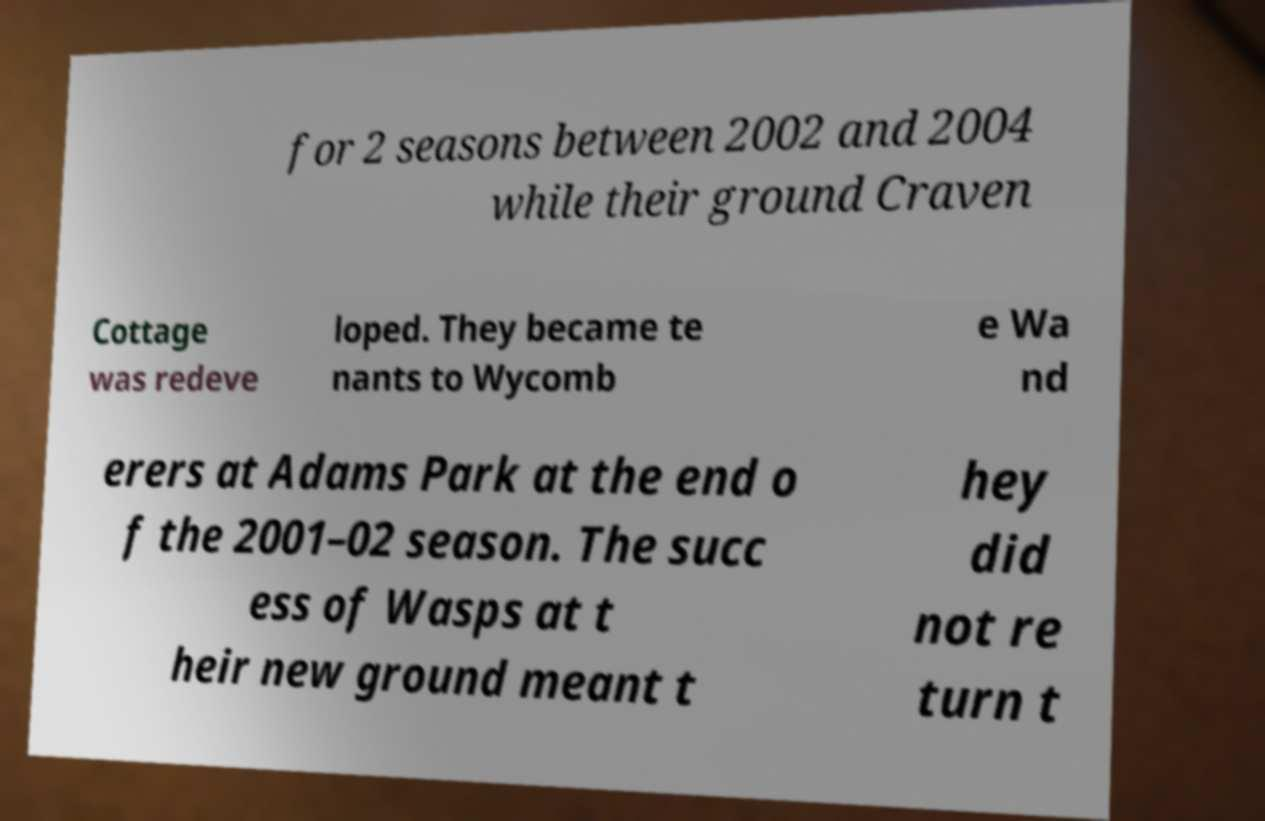Could you assist in decoding the text presented in this image and type it out clearly? for 2 seasons between 2002 and 2004 while their ground Craven Cottage was redeve loped. They became te nants to Wycomb e Wa nd erers at Adams Park at the end o f the 2001–02 season. The succ ess of Wasps at t heir new ground meant t hey did not re turn t 